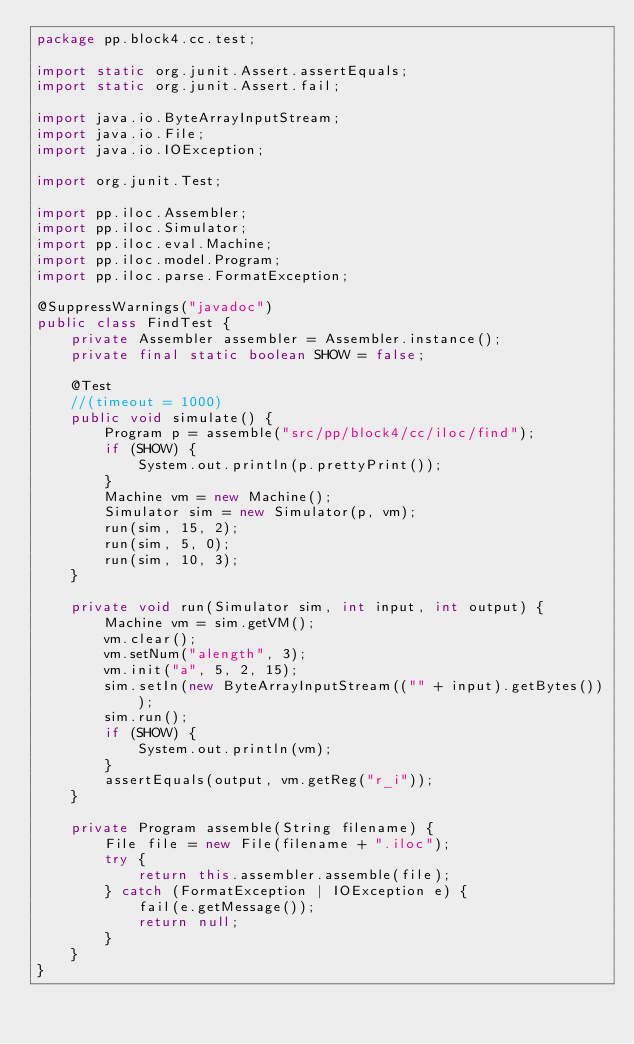<code> <loc_0><loc_0><loc_500><loc_500><_Java_>package pp.block4.cc.test;

import static org.junit.Assert.assertEquals;
import static org.junit.Assert.fail;

import java.io.ByteArrayInputStream;
import java.io.File;
import java.io.IOException;

import org.junit.Test;

import pp.iloc.Assembler;
import pp.iloc.Simulator;
import pp.iloc.eval.Machine;
import pp.iloc.model.Program;
import pp.iloc.parse.FormatException;

@SuppressWarnings("javadoc")
public class FindTest {
	private Assembler assembler = Assembler.instance();
	private final static boolean SHOW = false;

	@Test
	//(timeout = 1000)
	public void simulate() {
		Program p = assemble("src/pp/block4/cc/iloc/find");
		if (SHOW) {
			System.out.println(p.prettyPrint());
		}
		Machine vm = new Machine();
		Simulator sim = new Simulator(p, vm);
		run(sim, 15, 2);
		run(sim, 5, 0);
		run(sim, 10, 3);
	}

	private void run(Simulator sim, int input, int output) {
		Machine vm = sim.getVM();
		vm.clear();
		vm.setNum("alength", 3);
		vm.init("a", 5, 2, 15);
		sim.setIn(new ByteArrayInputStream(("" + input).getBytes()));
		sim.run();
		if (SHOW) {
			System.out.println(vm);
		}
		assertEquals(output, vm.getReg("r_i"));
	}

	private Program assemble(String filename) {
		File file = new File(filename + ".iloc");
		try {
			return this.assembler.assemble(file);
		} catch (FormatException | IOException e) {
			fail(e.getMessage());
			return null;
		}
	}
}
</code> 